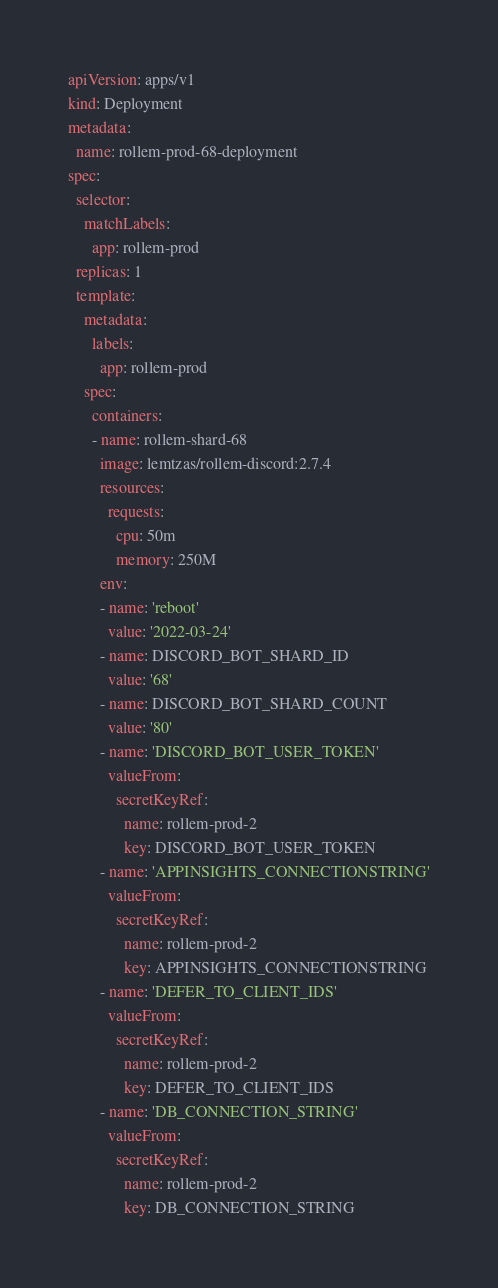Convert code to text. <code><loc_0><loc_0><loc_500><loc_500><_YAML_>apiVersion: apps/v1
kind: Deployment
metadata:
  name: rollem-prod-68-deployment
spec:
  selector:
    matchLabels:
      app: rollem-prod
  replicas: 1
  template:
    metadata:
      labels:
        app: rollem-prod
    spec:
      containers:
      - name: rollem-shard-68
        image: lemtzas/rollem-discord:2.7.4
        resources:
          requests:
            cpu: 50m
            memory: 250M
        env:
        - name: 'reboot'
          value: '2022-03-24'
        - name: DISCORD_BOT_SHARD_ID
          value: '68'
        - name: DISCORD_BOT_SHARD_COUNT
          value: '80'
        - name: 'DISCORD_BOT_USER_TOKEN'
          valueFrom:
            secretKeyRef:
              name: rollem-prod-2
              key: DISCORD_BOT_USER_TOKEN
        - name: 'APPINSIGHTS_CONNECTIONSTRING'
          valueFrom:
            secretKeyRef:
              name: rollem-prod-2
              key: APPINSIGHTS_CONNECTIONSTRING
        - name: 'DEFER_TO_CLIENT_IDS'
          valueFrom:
            secretKeyRef:
              name: rollem-prod-2
              key: DEFER_TO_CLIENT_IDS
        - name: 'DB_CONNECTION_STRING'
          valueFrom:
            secretKeyRef:
              name: rollem-prod-2
              key: DB_CONNECTION_STRING</code> 